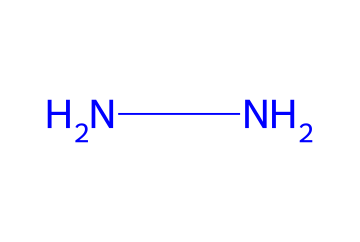What is the molecular formula of hydrazine? In the SMILES representation "NN", each "N" stands for a nitrogen atom. There are two nitrogen atoms and by knowing that hydrazine's common formula comprises two nitrogen atoms and four hydrogen atoms, we can deduce the molecular formula.
Answer: N2H4 How many nitrogen atoms are present? The visual representation "NN" clearly shows two nitrogen atoms adjacent to each other, indicating their presence.
Answer: 2 What type of chemical compound is hydrazine classified as? Hydrazine is classified as a hydrazine, a type of compound characterized by its two nitrogen atoms bonded together, thus placing it in that specific category.
Answer: hydrazine How many total hydrogen atoms are typically associated with hydrazine? Each nitrogen atom in hydrazine is generally bonded to two hydrogen atoms, resulting in a total of four hydrogen atoms when summing them up.
Answer: 4 What type of bonding is primarily present in hydrazine? The presence of the nitrogen-nitrogen bond (shown by the connection in "NN") indicates a covalent bond, which is typical for non-metal atoms sharing electrons.
Answer: covalent Is hydrazine a stable compound under standard conditions? Although the SMILES representation suggests a simple molecular structure, hydrazine is actually known to be unstable and can decompose under certain conditions, such as heat and pressure.
Answer: no What is the primary use of hydrazine in aviation? Hydrazine is primarily utilized as a propellant in rocket engines due to its high energy content and ability to produce thrust when undergoing rapid decomposition.
Answer: propellant 